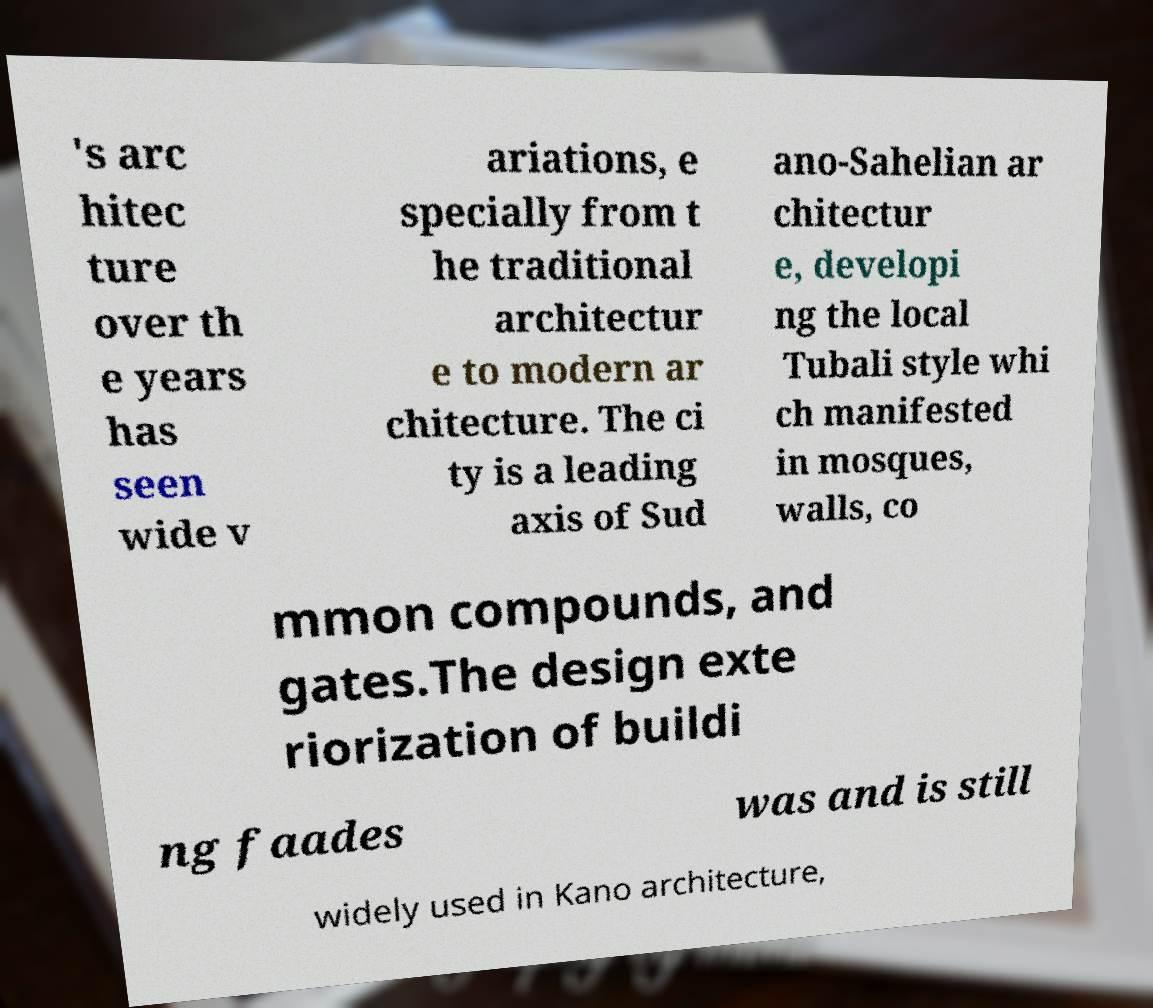What messages or text are displayed in this image? I need them in a readable, typed format. 's arc hitec ture over th e years has seen wide v ariations, e specially from t he traditional architectur e to modern ar chitecture. The ci ty is a leading axis of Sud ano-Sahelian ar chitectur e, developi ng the local Tubali style whi ch manifested in mosques, walls, co mmon compounds, and gates.The design exte riorization of buildi ng faades was and is still widely used in Kano architecture, 